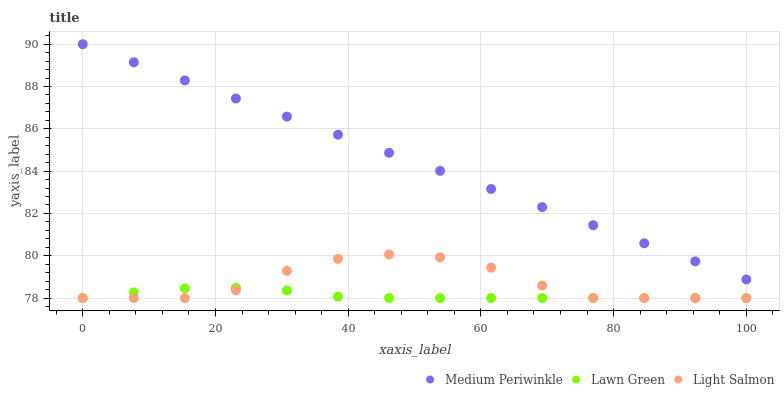Does Lawn Green have the minimum area under the curve?
Answer yes or no. Yes. Does Medium Periwinkle have the maximum area under the curve?
Answer yes or no. Yes. Does Light Salmon have the minimum area under the curve?
Answer yes or no. No. Does Light Salmon have the maximum area under the curve?
Answer yes or no. No. Is Medium Periwinkle the smoothest?
Answer yes or no. Yes. Is Light Salmon the roughest?
Answer yes or no. Yes. Is Light Salmon the smoothest?
Answer yes or no. No. Is Medium Periwinkle the roughest?
Answer yes or no. No. Does Lawn Green have the lowest value?
Answer yes or no. Yes. Does Medium Periwinkle have the lowest value?
Answer yes or no. No. Does Medium Periwinkle have the highest value?
Answer yes or no. Yes. Does Light Salmon have the highest value?
Answer yes or no. No. Is Lawn Green less than Medium Periwinkle?
Answer yes or no. Yes. Is Medium Periwinkle greater than Lawn Green?
Answer yes or no. Yes. Does Light Salmon intersect Lawn Green?
Answer yes or no. Yes. Is Light Salmon less than Lawn Green?
Answer yes or no. No. Is Light Salmon greater than Lawn Green?
Answer yes or no. No. Does Lawn Green intersect Medium Periwinkle?
Answer yes or no. No. 